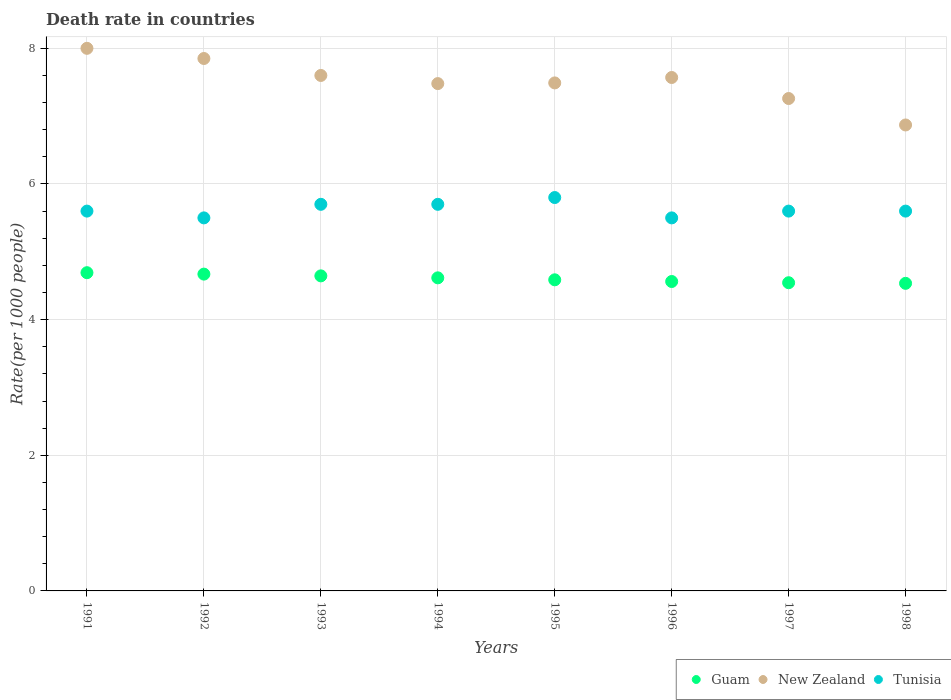How many different coloured dotlines are there?
Provide a succinct answer. 3. Is the number of dotlines equal to the number of legend labels?
Offer a very short reply. Yes. What is the death rate in Guam in 1996?
Keep it short and to the point. 4.56. Across all years, what is the maximum death rate in Guam?
Offer a very short reply. 4.69. Across all years, what is the minimum death rate in New Zealand?
Your answer should be compact. 6.87. In which year was the death rate in New Zealand maximum?
Provide a short and direct response. 1991. What is the total death rate in Guam in the graph?
Offer a terse response. 36.85. What is the difference between the death rate in Tunisia in 1992 and that in 1996?
Give a very brief answer. 0. What is the difference between the death rate in Tunisia in 1998 and the death rate in New Zealand in 1996?
Your answer should be very brief. -1.97. What is the average death rate in New Zealand per year?
Provide a short and direct response. 7.51. In the year 1997, what is the difference between the death rate in New Zealand and death rate in Guam?
Give a very brief answer. 2.72. What is the ratio of the death rate in Tunisia in 1991 to that in 1996?
Ensure brevity in your answer.  1.02. Is the difference between the death rate in New Zealand in 1994 and 1998 greater than the difference between the death rate in Guam in 1994 and 1998?
Make the answer very short. Yes. What is the difference between the highest and the second highest death rate in Guam?
Keep it short and to the point. 0.02. What is the difference between the highest and the lowest death rate in Tunisia?
Provide a short and direct response. 0.3. Is the sum of the death rate in New Zealand in 1993 and 1996 greater than the maximum death rate in Tunisia across all years?
Offer a very short reply. Yes. Does the death rate in New Zealand monotonically increase over the years?
Ensure brevity in your answer.  No. Is the death rate in Tunisia strictly greater than the death rate in Guam over the years?
Give a very brief answer. Yes. How many dotlines are there?
Your response must be concise. 3. Are the values on the major ticks of Y-axis written in scientific E-notation?
Provide a succinct answer. No. How are the legend labels stacked?
Your answer should be very brief. Horizontal. What is the title of the graph?
Ensure brevity in your answer.  Death rate in countries. What is the label or title of the Y-axis?
Keep it short and to the point. Rate(per 1000 people). What is the Rate(per 1000 people) of Guam in 1991?
Your response must be concise. 4.69. What is the Rate(per 1000 people) of Tunisia in 1991?
Your answer should be compact. 5.6. What is the Rate(per 1000 people) in Guam in 1992?
Offer a terse response. 4.67. What is the Rate(per 1000 people) of New Zealand in 1992?
Make the answer very short. 7.85. What is the Rate(per 1000 people) of Tunisia in 1992?
Ensure brevity in your answer.  5.5. What is the Rate(per 1000 people) of Guam in 1993?
Ensure brevity in your answer.  4.64. What is the Rate(per 1000 people) of New Zealand in 1993?
Provide a short and direct response. 7.6. What is the Rate(per 1000 people) in Guam in 1994?
Make the answer very short. 4.62. What is the Rate(per 1000 people) of New Zealand in 1994?
Your answer should be very brief. 7.48. What is the Rate(per 1000 people) in Tunisia in 1994?
Make the answer very short. 5.7. What is the Rate(per 1000 people) in Guam in 1995?
Offer a terse response. 4.59. What is the Rate(per 1000 people) of New Zealand in 1995?
Offer a very short reply. 7.49. What is the Rate(per 1000 people) in Tunisia in 1995?
Your answer should be compact. 5.8. What is the Rate(per 1000 people) in Guam in 1996?
Give a very brief answer. 4.56. What is the Rate(per 1000 people) of New Zealand in 1996?
Provide a succinct answer. 7.57. What is the Rate(per 1000 people) in Guam in 1997?
Your response must be concise. 4.54. What is the Rate(per 1000 people) in New Zealand in 1997?
Your answer should be compact. 7.26. What is the Rate(per 1000 people) of Tunisia in 1997?
Provide a succinct answer. 5.6. What is the Rate(per 1000 people) of Guam in 1998?
Your response must be concise. 4.54. What is the Rate(per 1000 people) of New Zealand in 1998?
Offer a terse response. 6.87. Across all years, what is the maximum Rate(per 1000 people) of Guam?
Your answer should be compact. 4.69. Across all years, what is the minimum Rate(per 1000 people) in Guam?
Your answer should be compact. 4.54. Across all years, what is the minimum Rate(per 1000 people) of New Zealand?
Ensure brevity in your answer.  6.87. Across all years, what is the minimum Rate(per 1000 people) in Tunisia?
Offer a terse response. 5.5. What is the total Rate(per 1000 people) in Guam in the graph?
Provide a short and direct response. 36.85. What is the total Rate(per 1000 people) of New Zealand in the graph?
Provide a short and direct response. 60.12. What is the total Rate(per 1000 people) of Tunisia in the graph?
Keep it short and to the point. 45. What is the difference between the Rate(per 1000 people) in Guam in 1991 and that in 1992?
Provide a short and direct response. 0.02. What is the difference between the Rate(per 1000 people) of New Zealand in 1991 and that in 1992?
Provide a short and direct response. 0.15. What is the difference between the Rate(per 1000 people) of Guam in 1991 and that in 1993?
Offer a terse response. 0.05. What is the difference between the Rate(per 1000 people) in New Zealand in 1991 and that in 1993?
Ensure brevity in your answer.  0.4. What is the difference between the Rate(per 1000 people) of Tunisia in 1991 and that in 1993?
Keep it short and to the point. -0.1. What is the difference between the Rate(per 1000 people) in Guam in 1991 and that in 1994?
Your answer should be compact. 0.08. What is the difference between the Rate(per 1000 people) of New Zealand in 1991 and that in 1994?
Your answer should be compact. 0.52. What is the difference between the Rate(per 1000 people) in Tunisia in 1991 and that in 1994?
Keep it short and to the point. -0.1. What is the difference between the Rate(per 1000 people) of Guam in 1991 and that in 1995?
Provide a short and direct response. 0.1. What is the difference between the Rate(per 1000 people) of New Zealand in 1991 and that in 1995?
Make the answer very short. 0.51. What is the difference between the Rate(per 1000 people) in Guam in 1991 and that in 1996?
Ensure brevity in your answer.  0.13. What is the difference between the Rate(per 1000 people) of New Zealand in 1991 and that in 1996?
Offer a terse response. 0.43. What is the difference between the Rate(per 1000 people) in Tunisia in 1991 and that in 1996?
Ensure brevity in your answer.  0.1. What is the difference between the Rate(per 1000 people) of Guam in 1991 and that in 1997?
Keep it short and to the point. 0.15. What is the difference between the Rate(per 1000 people) of New Zealand in 1991 and that in 1997?
Provide a short and direct response. 0.74. What is the difference between the Rate(per 1000 people) of Tunisia in 1991 and that in 1997?
Offer a very short reply. 0. What is the difference between the Rate(per 1000 people) of Guam in 1991 and that in 1998?
Provide a succinct answer. 0.16. What is the difference between the Rate(per 1000 people) of New Zealand in 1991 and that in 1998?
Give a very brief answer. 1.13. What is the difference between the Rate(per 1000 people) in Guam in 1992 and that in 1993?
Your response must be concise. 0.03. What is the difference between the Rate(per 1000 people) in Tunisia in 1992 and that in 1993?
Give a very brief answer. -0.2. What is the difference between the Rate(per 1000 people) in Guam in 1992 and that in 1994?
Provide a short and direct response. 0.06. What is the difference between the Rate(per 1000 people) in New Zealand in 1992 and that in 1994?
Give a very brief answer. 0.37. What is the difference between the Rate(per 1000 people) of Guam in 1992 and that in 1995?
Make the answer very short. 0.08. What is the difference between the Rate(per 1000 people) in New Zealand in 1992 and that in 1995?
Your answer should be compact. 0.36. What is the difference between the Rate(per 1000 people) of Guam in 1992 and that in 1996?
Your response must be concise. 0.11. What is the difference between the Rate(per 1000 people) of New Zealand in 1992 and that in 1996?
Ensure brevity in your answer.  0.28. What is the difference between the Rate(per 1000 people) in Tunisia in 1992 and that in 1996?
Your response must be concise. 0. What is the difference between the Rate(per 1000 people) in Guam in 1992 and that in 1997?
Give a very brief answer. 0.13. What is the difference between the Rate(per 1000 people) in New Zealand in 1992 and that in 1997?
Your response must be concise. 0.59. What is the difference between the Rate(per 1000 people) of Guam in 1992 and that in 1998?
Ensure brevity in your answer.  0.14. What is the difference between the Rate(per 1000 people) of Tunisia in 1992 and that in 1998?
Your answer should be very brief. -0.1. What is the difference between the Rate(per 1000 people) in Guam in 1993 and that in 1994?
Your response must be concise. 0.03. What is the difference between the Rate(per 1000 people) of New Zealand in 1993 and that in 1994?
Ensure brevity in your answer.  0.12. What is the difference between the Rate(per 1000 people) in Tunisia in 1993 and that in 1994?
Your answer should be compact. 0. What is the difference between the Rate(per 1000 people) in Guam in 1993 and that in 1995?
Give a very brief answer. 0.06. What is the difference between the Rate(per 1000 people) in New Zealand in 1993 and that in 1995?
Offer a very short reply. 0.11. What is the difference between the Rate(per 1000 people) of Guam in 1993 and that in 1996?
Make the answer very short. 0.08. What is the difference between the Rate(per 1000 people) of Guam in 1993 and that in 1997?
Your answer should be compact. 0.1. What is the difference between the Rate(per 1000 people) in New Zealand in 1993 and that in 1997?
Give a very brief answer. 0.34. What is the difference between the Rate(per 1000 people) in Guam in 1993 and that in 1998?
Your response must be concise. 0.11. What is the difference between the Rate(per 1000 people) in New Zealand in 1993 and that in 1998?
Offer a terse response. 0.73. What is the difference between the Rate(per 1000 people) in Guam in 1994 and that in 1995?
Offer a very short reply. 0.03. What is the difference between the Rate(per 1000 people) of New Zealand in 1994 and that in 1995?
Your response must be concise. -0.01. What is the difference between the Rate(per 1000 people) in Guam in 1994 and that in 1996?
Give a very brief answer. 0.05. What is the difference between the Rate(per 1000 people) in New Zealand in 1994 and that in 1996?
Keep it short and to the point. -0.09. What is the difference between the Rate(per 1000 people) in Tunisia in 1994 and that in 1996?
Make the answer very short. 0.2. What is the difference between the Rate(per 1000 people) in Guam in 1994 and that in 1997?
Make the answer very short. 0.07. What is the difference between the Rate(per 1000 people) of New Zealand in 1994 and that in 1997?
Ensure brevity in your answer.  0.22. What is the difference between the Rate(per 1000 people) of Guam in 1994 and that in 1998?
Your answer should be compact. 0.08. What is the difference between the Rate(per 1000 people) in New Zealand in 1994 and that in 1998?
Make the answer very short. 0.61. What is the difference between the Rate(per 1000 people) of Tunisia in 1994 and that in 1998?
Your response must be concise. 0.1. What is the difference between the Rate(per 1000 people) of Guam in 1995 and that in 1996?
Give a very brief answer. 0.03. What is the difference between the Rate(per 1000 people) in New Zealand in 1995 and that in 1996?
Provide a short and direct response. -0.08. What is the difference between the Rate(per 1000 people) of Tunisia in 1995 and that in 1996?
Your answer should be compact. 0.3. What is the difference between the Rate(per 1000 people) in Guam in 1995 and that in 1997?
Provide a short and direct response. 0.04. What is the difference between the Rate(per 1000 people) of New Zealand in 1995 and that in 1997?
Ensure brevity in your answer.  0.23. What is the difference between the Rate(per 1000 people) of Guam in 1995 and that in 1998?
Keep it short and to the point. 0.05. What is the difference between the Rate(per 1000 people) of New Zealand in 1995 and that in 1998?
Your answer should be compact. 0.62. What is the difference between the Rate(per 1000 people) of Guam in 1996 and that in 1997?
Make the answer very short. 0.02. What is the difference between the Rate(per 1000 people) in New Zealand in 1996 and that in 1997?
Your response must be concise. 0.31. What is the difference between the Rate(per 1000 people) of Tunisia in 1996 and that in 1997?
Ensure brevity in your answer.  -0.1. What is the difference between the Rate(per 1000 people) of Guam in 1996 and that in 1998?
Offer a terse response. 0.03. What is the difference between the Rate(per 1000 people) of Guam in 1997 and that in 1998?
Give a very brief answer. 0.01. What is the difference between the Rate(per 1000 people) in New Zealand in 1997 and that in 1998?
Offer a terse response. 0.39. What is the difference between the Rate(per 1000 people) in Guam in 1991 and the Rate(per 1000 people) in New Zealand in 1992?
Give a very brief answer. -3.16. What is the difference between the Rate(per 1000 people) of Guam in 1991 and the Rate(per 1000 people) of Tunisia in 1992?
Your answer should be very brief. -0.81. What is the difference between the Rate(per 1000 people) in Guam in 1991 and the Rate(per 1000 people) in New Zealand in 1993?
Make the answer very short. -2.91. What is the difference between the Rate(per 1000 people) of Guam in 1991 and the Rate(per 1000 people) of Tunisia in 1993?
Give a very brief answer. -1.01. What is the difference between the Rate(per 1000 people) in New Zealand in 1991 and the Rate(per 1000 people) in Tunisia in 1993?
Your response must be concise. 2.3. What is the difference between the Rate(per 1000 people) of Guam in 1991 and the Rate(per 1000 people) of New Zealand in 1994?
Your answer should be compact. -2.79. What is the difference between the Rate(per 1000 people) of Guam in 1991 and the Rate(per 1000 people) of Tunisia in 1994?
Give a very brief answer. -1.01. What is the difference between the Rate(per 1000 people) of Guam in 1991 and the Rate(per 1000 people) of New Zealand in 1995?
Ensure brevity in your answer.  -2.8. What is the difference between the Rate(per 1000 people) of Guam in 1991 and the Rate(per 1000 people) of Tunisia in 1995?
Provide a succinct answer. -1.11. What is the difference between the Rate(per 1000 people) in New Zealand in 1991 and the Rate(per 1000 people) in Tunisia in 1995?
Keep it short and to the point. 2.2. What is the difference between the Rate(per 1000 people) in Guam in 1991 and the Rate(per 1000 people) in New Zealand in 1996?
Your answer should be very brief. -2.88. What is the difference between the Rate(per 1000 people) in Guam in 1991 and the Rate(per 1000 people) in Tunisia in 1996?
Provide a short and direct response. -0.81. What is the difference between the Rate(per 1000 people) in Guam in 1991 and the Rate(per 1000 people) in New Zealand in 1997?
Make the answer very short. -2.57. What is the difference between the Rate(per 1000 people) of Guam in 1991 and the Rate(per 1000 people) of Tunisia in 1997?
Offer a terse response. -0.91. What is the difference between the Rate(per 1000 people) of New Zealand in 1991 and the Rate(per 1000 people) of Tunisia in 1997?
Give a very brief answer. 2.4. What is the difference between the Rate(per 1000 people) in Guam in 1991 and the Rate(per 1000 people) in New Zealand in 1998?
Ensure brevity in your answer.  -2.18. What is the difference between the Rate(per 1000 people) of Guam in 1991 and the Rate(per 1000 people) of Tunisia in 1998?
Offer a very short reply. -0.91. What is the difference between the Rate(per 1000 people) of Guam in 1992 and the Rate(per 1000 people) of New Zealand in 1993?
Ensure brevity in your answer.  -2.93. What is the difference between the Rate(per 1000 people) in Guam in 1992 and the Rate(per 1000 people) in Tunisia in 1993?
Make the answer very short. -1.03. What is the difference between the Rate(per 1000 people) in New Zealand in 1992 and the Rate(per 1000 people) in Tunisia in 1993?
Provide a short and direct response. 2.15. What is the difference between the Rate(per 1000 people) of Guam in 1992 and the Rate(per 1000 people) of New Zealand in 1994?
Offer a terse response. -2.81. What is the difference between the Rate(per 1000 people) of Guam in 1992 and the Rate(per 1000 people) of Tunisia in 1994?
Ensure brevity in your answer.  -1.03. What is the difference between the Rate(per 1000 people) of New Zealand in 1992 and the Rate(per 1000 people) of Tunisia in 1994?
Give a very brief answer. 2.15. What is the difference between the Rate(per 1000 people) of Guam in 1992 and the Rate(per 1000 people) of New Zealand in 1995?
Offer a terse response. -2.82. What is the difference between the Rate(per 1000 people) of Guam in 1992 and the Rate(per 1000 people) of Tunisia in 1995?
Your response must be concise. -1.13. What is the difference between the Rate(per 1000 people) of New Zealand in 1992 and the Rate(per 1000 people) of Tunisia in 1995?
Provide a short and direct response. 2.05. What is the difference between the Rate(per 1000 people) in Guam in 1992 and the Rate(per 1000 people) in New Zealand in 1996?
Keep it short and to the point. -2.9. What is the difference between the Rate(per 1000 people) in Guam in 1992 and the Rate(per 1000 people) in Tunisia in 1996?
Offer a very short reply. -0.83. What is the difference between the Rate(per 1000 people) in New Zealand in 1992 and the Rate(per 1000 people) in Tunisia in 1996?
Provide a short and direct response. 2.35. What is the difference between the Rate(per 1000 people) in Guam in 1992 and the Rate(per 1000 people) in New Zealand in 1997?
Provide a short and direct response. -2.59. What is the difference between the Rate(per 1000 people) in Guam in 1992 and the Rate(per 1000 people) in Tunisia in 1997?
Your response must be concise. -0.93. What is the difference between the Rate(per 1000 people) in New Zealand in 1992 and the Rate(per 1000 people) in Tunisia in 1997?
Ensure brevity in your answer.  2.25. What is the difference between the Rate(per 1000 people) of Guam in 1992 and the Rate(per 1000 people) of New Zealand in 1998?
Your answer should be very brief. -2.2. What is the difference between the Rate(per 1000 people) of Guam in 1992 and the Rate(per 1000 people) of Tunisia in 1998?
Your answer should be compact. -0.93. What is the difference between the Rate(per 1000 people) of New Zealand in 1992 and the Rate(per 1000 people) of Tunisia in 1998?
Your answer should be compact. 2.25. What is the difference between the Rate(per 1000 people) in Guam in 1993 and the Rate(per 1000 people) in New Zealand in 1994?
Keep it short and to the point. -2.83. What is the difference between the Rate(per 1000 people) of Guam in 1993 and the Rate(per 1000 people) of Tunisia in 1994?
Your answer should be very brief. -1.05. What is the difference between the Rate(per 1000 people) of New Zealand in 1993 and the Rate(per 1000 people) of Tunisia in 1994?
Offer a terse response. 1.9. What is the difference between the Rate(per 1000 people) in Guam in 1993 and the Rate(per 1000 people) in New Zealand in 1995?
Your answer should be very brief. -2.85. What is the difference between the Rate(per 1000 people) of Guam in 1993 and the Rate(per 1000 people) of Tunisia in 1995?
Your response must be concise. -1.16. What is the difference between the Rate(per 1000 people) of Guam in 1993 and the Rate(per 1000 people) of New Zealand in 1996?
Provide a short and direct response. -2.92. What is the difference between the Rate(per 1000 people) in Guam in 1993 and the Rate(per 1000 people) in Tunisia in 1996?
Give a very brief answer. -0.85. What is the difference between the Rate(per 1000 people) of New Zealand in 1993 and the Rate(per 1000 people) of Tunisia in 1996?
Give a very brief answer. 2.1. What is the difference between the Rate(per 1000 people) in Guam in 1993 and the Rate(per 1000 people) in New Zealand in 1997?
Offer a very short reply. -2.62. What is the difference between the Rate(per 1000 people) in Guam in 1993 and the Rate(per 1000 people) in Tunisia in 1997?
Offer a terse response. -0.95. What is the difference between the Rate(per 1000 people) of Guam in 1993 and the Rate(per 1000 people) of New Zealand in 1998?
Give a very brief answer. -2.23. What is the difference between the Rate(per 1000 people) in Guam in 1993 and the Rate(per 1000 people) in Tunisia in 1998?
Your response must be concise. -0.95. What is the difference between the Rate(per 1000 people) of New Zealand in 1993 and the Rate(per 1000 people) of Tunisia in 1998?
Offer a very short reply. 2. What is the difference between the Rate(per 1000 people) of Guam in 1994 and the Rate(per 1000 people) of New Zealand in 1995?
Offer a very short reply. -2.87. What is the difference between the Rate(per 1000 people) of Guam in 1994 and the Rate(per 1000 people) of Tunisia in 1995?
Your answer should be compact. -1.18. What is the difference between the Rate(per 1000 people) in New Zealand in 1994 and the Rate(per 1000 people) in Tunisia in 1995?
Offer a very short reply. 1.68. What is the difference between the Rate(per 1000 people) in Guam in 1994 and the Rate(per 1000 people) in New Zealand in 1996?
Offer a very short reply. -2.95. What is the difference between the Rate(per 1000 people) of Guam in 1994 and the Rate(per 1000 people) of Tunisia in 1996?
Make the answer very short. -0.88. What is the difference between the Rate(per 1000 people) of New Zealand in 1994 and the Rate(per 1000 people) of Tunisia in 1996?
Give a very brief answer. 1.98. What is the difference between the Rate(per 1000 people) of Guam in 1994 and the Rate(per 1000 people) of New Zealand in 1997?
Your answer should be very brief. -2.64. What is the difference between the Rate(per 1000 people) of Guam in 1994 and the Rate(per 1000 people) of Tunisia in 1997?
Your answer should be compact. -0.98. What is the difference between the Rate(per 1000 people) in New Zealand in 1994 and the Rate(per 1000 people) in Tunisia in 1997?
Provide a short and direct response. 1.88. What is the difference between the Rate(per 1000 people) of Guam in 1994 and the Rate(per 1000 people) of New Zealand in 1998?
Offer a very short reply. -2.25. What is the difference between the Rate(per 1000 people) in Guam in 1994 and the Rate(per 1000 people) in Tunisia in 1998?
Keep it short and to the point. -0.98. What is the difference between the Rate(per 1000 people) of New Zealand in 1994 and the Rate(per 1000 people) of Tunisia in 1998?
Provide a short and direct response. 1.88. What is the difference between the Rate(per 1000 people) in Guam in 1995 and the Rate(per 1000 people) in New Zealand in 1996?
Your response must be concise. -2.98. What is the difference between the Rate(per 1000 people) of Guam in 1995 and the Rate(per 1000 people) of Tunisia in 1996?
Make the answer very short. -0.91. What is the difference between the Rate(per 1000 people) of New Zealand in 1995 and the Rate(per 1000 people) of Tunisia in 1996?
Offer a very short reply. 1.99. What is the difference between the Rate(per 1000 people) of Guam in 1995 and the Rate(per 1000 people) of New Zealand in 1997?
Provide a succinct answer. -2.67. What is the difference between the Rate(per 1000 people) of Guam in 1995 and the Rate(per 1000 people) of Tunisia in 1997?
Ensure brevity in your answer.  -1.01. What is the difference between the Rate(per 1000 people) of New Zealand in 1995 and the Rate(per 1000 people) of Tunisia in 1997?
Give a very brief answer. 1.89. What is the difference between the Rate(per 1000 people) of Guam in 1995 and the Rate(per 1000 people) of New Zealand in 1998?
Keep it short and to the point. -2.28. What is the difference between the Rate(per 1000 people) of Guam in 1995 and the Rate(per 1000 people) of Tunisia in 1998?
Ensure brevity in your answer.  -1.01. What is the difference between the Rate(per 1000 people) of New Zealand in 1995 and the Rate(per 1000 people) of Tunisia in 1998?
Your answer should be very brief. 1.89. What is the difference between the Rate(per 1000 people) of Guam in 1996 and the Rate(per 1000 people) of New Zealand in 1997?
Offer a very short reply. -2.7. What is the difference between the Rate(per 1000 people) in Guam in 1996 and the Rate(per 1000 people) in Tunisia in 1997?
Provide a succinct answer. -1.04. What is the difference between the Rate(per 1000 people) in New Zealand in 1996 and the Rate(per 1000 people) in Tunisia in 1997?
Your answer should be compact. 1.97. What is the difference between the Rate(per 1000 people) in Guam in 1996 and the Rate(per 1000 people) in New Zealand in 1998?
Keep it short and to the point. -2.31. What is the difference between the Rate(per 1000 people) in Guam in 1996 and the Rate(per 1000 people) in Tunisia in 1998?
Keep it short and to the point. -1.04. What is the difference between the Rate(per 1000 people) in New Zealand in 1996 and the Rate(per 1000 people) in Tunisia in 1998?
Your answer should be compact. 1.97. What is the difference between the Rate(per 1000 people) in Guam in 1997 and the Rate(per 1000 people) in New Zealand in 1998?
Make the answer very short. -2.33. What is the difference between the Rate(per 1000 people) of Guam in 1997 and the Rate(per 1000 people) of Tunisia in 1998?
Your response must be concise. -1.06. What is the difference between the Rate(per 1000 people) of New Zealand in 1997 and the Rate(per 1000 people) of Tunisia in 1998?
Offer a terse response. 1.66. What is the average Rate(per 1000 people) in Guam per year?
Give a very brief answer. 4.61. What is the average Rate(per 1000 people) of New Zealand per year?
Provide a succinct answer. 7.51. What is the average Rate(per 1000 people) of Tunisia per year?
Your response must be concise. 5.62. In the year 1991, what is the difference between the Rate(per 1000 people) in Guam and Rate(per 1000 people) in New Zealand?
Give a very brief answer. -3.31. In the year 1991, what is the difference between the Rate(per 1000 people) of Guam and Rate(per 1000 people) of Tunisia?
Make the answer very short. -0.91. In the year 1991, what is the difference between the Rate(per 1000 people) in New Zealand and Rate(per 1000 people) in Tunisia?
Your answer should be very brief. 2.4. In the year 1992, what is the difference between the Rate(per 1000 people) of Guam and Rate(per 1000 people) of New Zealand?
Provide a short and direct response. -3.18. In the year 1992, what is the difference between the Rate(per 1000 people) of Guam and Rate(per 1000 people) of Tunisia?
Offer a terse response. -0.83. In the year 1992, what is the difference between the Rate(per 1000 people) of New Zealand and Rate(per 1000 people) of Tunisia?
Give a very brief answer. 2.35. In the year 1993, what is the difference between the Rate(per 1000 people) of Guam and Rate(per 1000 people) of New Zealand?
Offer a very short reply. -2.96. In the year 1993, what is the difference between the Rate(per 1000 people) in Guam and Rate(per 1000 people) in Tunisia?
Your response must be concise. -1.05. In the year 1994, what is the difference between the Rate(per 1000 people) of Guam and Rate(per 1000 people) of New Zealand?
Give a very brief answer. -2.86. In the year 1994, what is the difference between the Rate(per 1000 people) in Guam and Rate(per 1000 people) in Tunisia?
Your answer should be very brief. -1.08. In the year 1994, what is the difference between the Rate(per 1000 people) of New Zealand and Rate(per 1000 people) of Tunisia?
Your response must be concise. 1.78. In the year 1995, what is the difference between the Rate(per 1000 people) in Guam and Rate(per 1000 people) in New Zealand?
Offer a very short reply. -2.9. In the year 1995, what is the difference between the Rate(per 1000 people) in Guam and Rate(per 1000 people) in Tunisia?
Give a very brief answer. -1.21. In the year 1995, what is the difference between the Rate(per 1000 people) of New Zealand and Rate(per 1000 people) of Tunisia?
Provide a succinct answer. 1.69. In the year 1996, what is the difference between the Rate(per 1000 people) in Guam and Rate(per 1000 people) in New Zealand?
Keep it short and to the point. -3.01. In the year 1996, what is the difference between the Rate(per 1000 people) of Guam and Rate(per 1000 people) of Tunisia?
Offer a very short reply. -0.94. In the year 1996, what is the difference between the Rate(per 1000 people) of New Zealand and Rate(per 1000 people) of Tunisia?
Provide a succinct answer. 2.07. In the year 1997, what is the difference between the Rate(per 1000 people) of Guam and Rate(per 1000 people) of New Zealand?
Offer a very short reply. -2.72. In the year 1997, what is the difference between the Rate(per 1000 people) of Guam and Rate(per 1000 people) of Tunisia?
Give a very brief answer. -1.06. In the year 1997, what is the difference between the Rate(per 1000 people) of New Zealand and Rate(per 1000 people) of Tunisia?
Keep it short and to the point. 1.66. In the year 1998, what is the difference between the Rate(per 1000 people) of Guam and Rate(per 1000 people) of New Zealand?
Make the answer very short. -2.33. In the year 1998, what is the difference between the Rate(per 1000 people) of Guam and Rate(per 1000 people) of Tunisia?
Make the answer very short. -1.06. In the year 1998, what is the difference between the Rate(per 1000 people) in New Zealand and Rate(per 1000 people) in Tunisia?
Give a very brief answer. 1.27. What is the ratio of the Rate(per 1000 people) in Guam in 1991 to that in 1992?
Your answer should be very brief. 1. What is the ratio of the Rate(per 1000 people) of New Zealand in 1991 to that in 1992?
Provide a short and direct response. 1.02. What is the ratio of the Rate(per 1000 people) in Tunisia in 1991 to that in 1992?
Offer a very short reply. 1.02. What is the ratio of the Rate(per 1000 people) in Guam in 1991 to that in 1993?
Keep it short and to the point. 1.01. What is the ratio of the Rate(per 1000 people) in New Zealand in 1991 to that in 1993?
Provide a succinct answer. 1.05. What is the ratio of the Rate(per 1000 people) in Tunisia in 1991 to that in 1993?
Make the answer very short. 0.98. What is the ratio of the Rate(per 1000 people) in Guam in 1991 to that in 1994?
Your answer should be very brief. 1.02. What is the ratio of the Rate(per 1000 people) of New Zealand in 1991 to that in 1994?
Your answer should be compact. 1.07. What is the ratio of the Rate(per 1000 people) in Tunisia in 1991 to that in 1994?
Give a very brief answer. 0.98. What is the ratio of the Rate(per 1000 people) of Guam in 1991 to that in 1995?
Keep it short and to the point. 1.02. What is the ratio of the Rate(per 1000 people) of New Zealand in 1991 to that in 1995?
Keep it short and to the point. 1.07. What is the ratio of the Rate(per 1000 people) in Tunisia in 1991 to that in 1995?
Offer a very short reply. 0.97. What is the ratio of the Rate(per 1000 people) of Guam in 1991 to that in 1996?
Offer a very short reply. 1.03. What is the ratio of the Rate(per 1000 people) in New Zealand in 1991 to that in 1996?
Your response must be concise. 1.06. What is the ratio of the Rate(per 1000 people) in Tunisia in 1991 to that in 1996?
Your response must be concise. 1.02. What is the ratio of the Rate(per 1000 people) in Guam in 1991 to that in 1997?
Offer a terse response. 1.03. What is the ratio of the Rate(per 1000 people) of New Zealand in 1991 to that in 1997?
Keep it short and to the point. 1.1. What is the ratio of the Rate(per 1000 people) of Guam in 1991 to that in 1998?
Make the answer very short. 1.03. What is the ratio of the Rate(per 1000 people) of New Zealand in 1991 to that in 1998?
Offer a very short reply. 1.16. What is the ratio of the Rate(per 1000 people) of Guam in 1992 to that in 1993?
Your answer should be very brief. 1.01. What is the ratio of the Rate(per 1000 people) of New Zealand in 1992 to that in 1993?
Offer a very short reply. 1.03. What is the ratio of the Rate(per 1000 people) of Tunisia in 1992 to that in 1993?
Keep it short and to the point. 0.96. What is the ratio of the Rate(per 1000 people) of Guam in 1992 to that in 1994?
Keep it short and to the point. 1.01. What is the ratio of the Rate(per 1000 people) in New Zealand in 1992 to that in 1994?
Your response must be concise. 1.05. What is the ratio of the Rate(per 1000 people) in Tunisia in 1992 to that in 1994?
Give a very brief answer. 0.96. What is the ratio of the Rate(per 1000 people) of Guam in 1992 to that in 1995?
Provide a short and direct response. 1.02. What is the ratio of the Rate(per 1000 people) of New Zealand in 1992 to that in 1995?
Offer a very short reply. 1.05. What is the ratio of the Rate(per 1000 people) of Tunisia in 1992 to that in 1995?
Ensure brevity in your answer.  0.95. What is the ratio of the Rate(per 1000 people) in Guam in 1992 to that in 1996?
Your answer should be very brief. 1.02. What is the ratio of the Rate(per 1000 people) of Tunisia in 1992 to that in 1996?
Your answer should be very brief. 1. What is the ratio of the Rate(per 1000 people) in Guam in 1992 to that in 1997?
Offer a terse response. 1.03. What is the ratio of the Rate(per 1000 people) in New Zealand in 1992 to that in 1997?
Your response must be concise. 1.08. What is the ratio of the Rate(per 1000 people) of Tunisia in 1992 to that in 1997?
Your answer should be very brief. 0.98. What is the ratio of the Rate(per 1000 people) in New Zealand in 1992 to that in 1998?
Give a very brief answer. 1.14. What is the ratio of the Rate(per 1000 people) of Tunisia in 1992 to that in 1998?
Make the answer very short. 0.98. What is the ratio of the Rate(per 1000 people) in Guam in 1993 to that in 1995?
Keep it short and to the point. 1.01. What is the ratio of the Rate(per 1000 people) in New Zealand in 1993 to that in 1995?
Offer a very short reply. 1.01. What is the ratio of the Rate(per 1000 people) in Tunisia in 1993 to that in 1995?
Give a very brief answer. 0.98. What is the ratio of the Rate(per 1000 people) of Guam in 1993 to that in 1996?
Your answer should be very brief. 1.02. What is the ratio of the Rate(per 1000 people) of Tunisia in 1993 to that in 1996?
Give a very brief answer. 1.04. What is the ratio of the Rate(per 1000 people) of Guam in 1993 to that in 1997?
Provide a short and direct response. 1.02. What is the ratio of the Rate(per 1000 people) in New Zealand in 1993 to that in 1997?
Give a very brief answer. 1.05. What is the ratio of the Rate(per 1000 people) of Tunisia in 1993 to that in 1997?
Give a very brief answer. 1.02. What is the ratio of the Rate(per 1000 people) in Guam in 1993 to that in 1998?
Your response must be concise. 1.02. What is the ratio of the Rate(per 1000 people) in New Zealand in 1993 to that in 1998?
Your answer should be compact. 1.11. What is the ratio of the Rate(per 1000 people) in Tunisia in 1993 to that in 1998?
Give a very brief answer. 1.02. What is the ratio of the Rate(per 1000 people) of Guam in 1994 to that in 1995?
Offer a terse response. 1.01. What is the ratio of the Rate(per 1000 people) in New Zealand in 1994 to that in 1995?
Provide a short and direct response. 1. What is the ratio of the Rate(per 1000 people) in Tunisia in 1994 to that in 1995?
Offer a very short reply. 0.98. What is the ratio of the Rate(per 1000 people) of Guam in 1994 to that in 1996?
Provide a succinct answer. 1.01. What is the ratio of the Rate(per 1000 people) of Tunisia in 1994 to that in 1996?
Your answer should be very brief. 1.04. What is the ratio of the Rate(per 1000 people) in Guam in 1994 to that in 1997?
Your answer should be very brief. 1.02. What is the ratio of the Rate(per 1000 people) of New Zealand in 1994 to that in 1997?
Your answer should be very brief. 1.03. What is the ratio of the Rate(per 1000 people) in Tunisia in 1994 to that in 1997?
Your response must be concise. 1.02. What is the ratio of the Rate(per 1000 people) in Guam in 1994 to that in 1998?
Ensure brevity in your answer.  1.02. What is the ratio of the Rate(per 1000 people) of New Zealand in 1994 to that in 1998?
Provide a short and direct response. 1.09. What is the ratio of the Rate(per 1000 people) in Tunisia in 1994 to that in 1998?
Your answer should be very brief. 1.02. What is the ratio of the Rate(per 1000 people) of Tunisia in 1995 to that in 1996?
Provide a succinct answer. 1.05. What is the ratio of the Rate(per 1000 people) of Guam in 1995 to that in 1997?
Offer a terse response. 1.01. What is the ratio of the Rate(per 1000 people) in New Zealand in 1995 to that in 1997?
Offer a terse response. 1.03. What is the ratio of the Rate(per 1000 people) in Tunisia in 1995 to that in 1997?
Provide a short and direct response. 1.04. What is the ratio of the Rate(per 1000 people) in Guam in 1995 to that in 1998?
Give a very brief answer. 1.01. What is the ratio of the Rate(per 1000 people) of New Zealand in 1995 to that in 1998?
Provide a short and direct response. 1.09. What is the ratio of the Rate(per 1000 people) in Tunisia in 1995 to that in 1998?
Keep it short and to the point. 1.04. What is the ratio of the Rate(per 1000 people) of New Zealand in 1996 to that in 1997?
Your response must be concise. 1.04. What is the ratio of the Rate(per 1000 people) of Tunisia in 1996 to that in 1997?
Keep it short and to the point. 0.98. What is the ratio of the Rate(per 1000 people) in Guam in 1996 to that in 1998?
Offer a very short reply. 1.01. What is the ratio of the Rate(per 1000 people) of New Zealand in 1996 to that in 1998?
Provide a succinct answer. 1.1. What is the ratio of the Rate(per 1000 people) of Tunisia in 1996 to that in 1998?
Ensure brevity in your answer.  0.98. What is the ratio of the Rate(per 1000 people) in New Zealand in 1997 to that in 1998?
Make the answer very short. 1.06. What is the difference between the highest and the second highest Rate(per 1000 people) in Guam?
Offer a terse response. 0.02. What is the difference between the highest and the second highest Rate(per 1000 people) of Tunisia?
Your response must be concise. 0.1. What is the difference between the highest and the lowest Rate(per 1000 people) of Guam?
Provide a short and direct response. 0.16. What is the difference between the highest and the lowest Rate(per 1000 people) of New Zealand?
Ensure brevity in your answer.  1.13. 